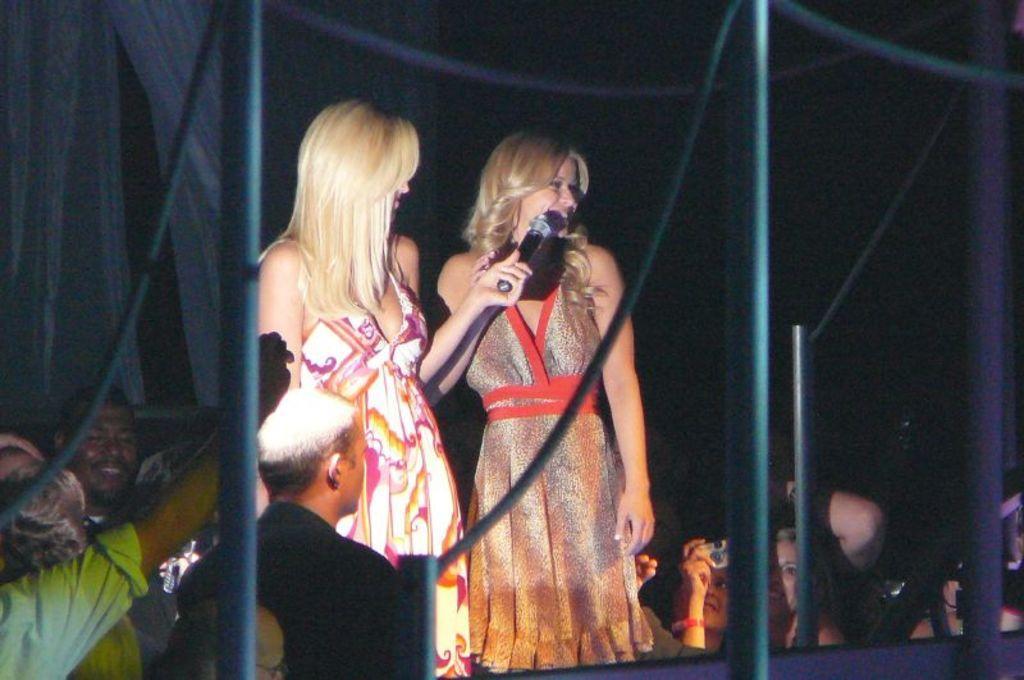Please provide a concise description of this image. In the picture it looks like some event, there are two women standing on the stage and around them there is a crowd, in front of the women there are few iron rods. 